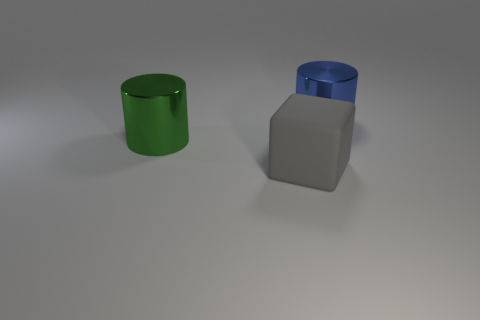Add 2 tiny cyan rubber balls. How many objects exist? 5 Subtract 0 gray cylinders. How many objects are left? 3 Subtract all cylinders. How many objects are left? 1 Subtract 2 cylinders. How many cylinders are left? 0 Subtract all yellow blocks. Subtract all brown spheres. How many blocks are left? 1 Subtract all brown spheres. How many blue cylinders are left? 1 Subtract all large green cylinders. Subtract all blue metal things. How many objects are left? 1 Add 1 large rubber blocks. How many large rubber blocks are left? 2 Add 3 large cyan objects. How many large cyan objects exist? 3 